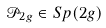Convert formula to latex. <formula><loc_0><loc_0><loc_500><loc_500>& \mathcal { P } _ { 2 g } \in S p ( 2 g )</formula> 